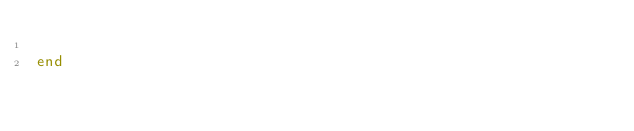Convert code to text. <code><loc_0><loc_0><loc_500><loc_500><_Ruby_>
end
</code> 